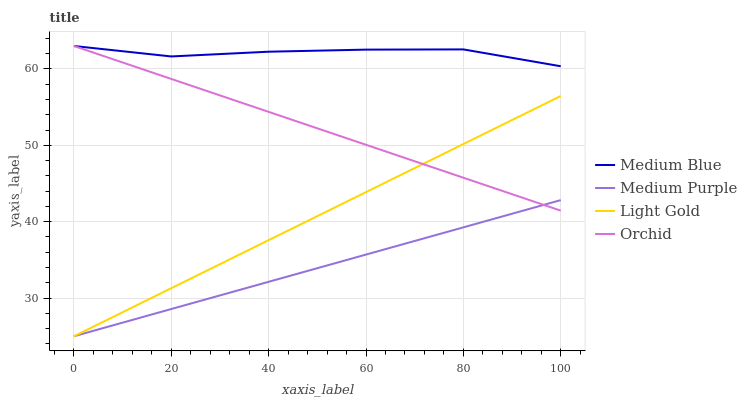Does Medium Purple have the minimum area under the curve?
Answer yes or no. Yes. Does Medium Blue have the maximum area under the curve?
Answer yes or no. Yes. Does Light Gold have the minimum area under the curve?
Answer yes or no. No. Does Light Gold have the maximum area under the curve?
Answer yes or no. No. Is Light Gold the smoothest?
Answer yes or no. Yes. Is Medium Blue the roughest?
Answer yes or no. Yes. Is Medium Blue the smoothest?
Answer yes or no. No. Is Light Gold the roughest?
Answer yes or no. No. Does Medium Purple have the lowest value?
Answer yes or no. Yes. Does Medium Blue have the lowest value?
Answer yes or no. No. Does Orchid have the highest value?
Answer yes or no. Yes. Does Light Gold have the highest value?
Answer yes or no. No. Is Medium Purple less than Medium Blue?
Answer yes or no. Yes. Is Medium Blue greater than Medium Purple?
Answer yes or no. Yes. Does Orchid intersect Light Gold?
Answer yes or no. Yes. Is Orchid less than Light Gold?
Answer yes or no. No. Is Orchid greater than Light Gold?
Answer yes or no. No. Does Medium Purple intersect Medium Blue?
Answer yes or no. No. 